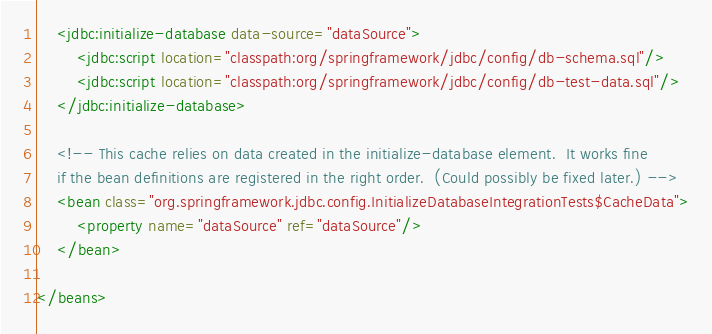Convert code to text. <code><loc_0><loc_0><loc_500><loc_500><_XML_>
	<jdbc:initialize-database data-source="dataSource">
		<jdbc:script location="classpath:org/springframework/jdbc/config/db-schema.sql"/>
		<jdbc:script location="classpath:org/springframework/jdbc/config/db-test-data.sql"/>
	</jdbc:initialize-database>

	<!-- This cache relies on data created in the initialize-database element.  It works fine
	if the bean definitions are registered in the right order.  (Could possibly be fixed later.) -->
	<bean class="org.springframework.jdbc.config.InitializeDatabaseIntegrationTests$CacheData">
		<property name="dataSource" ref="dataSource"/>
	</bean>

</beans>
</code> 